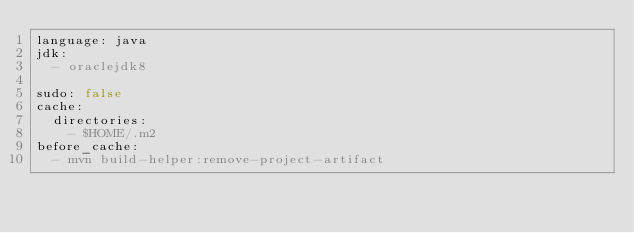<code> <loc_0><loc_0><loc_500><loc_500><_YAML_>language: java
jdk:
  - oraclejdk8

sudo: false
cache:
  directories:
    - $HOME/.m2
before_cache:
  - mvn build-helper:remove-project-artifact
</code> 